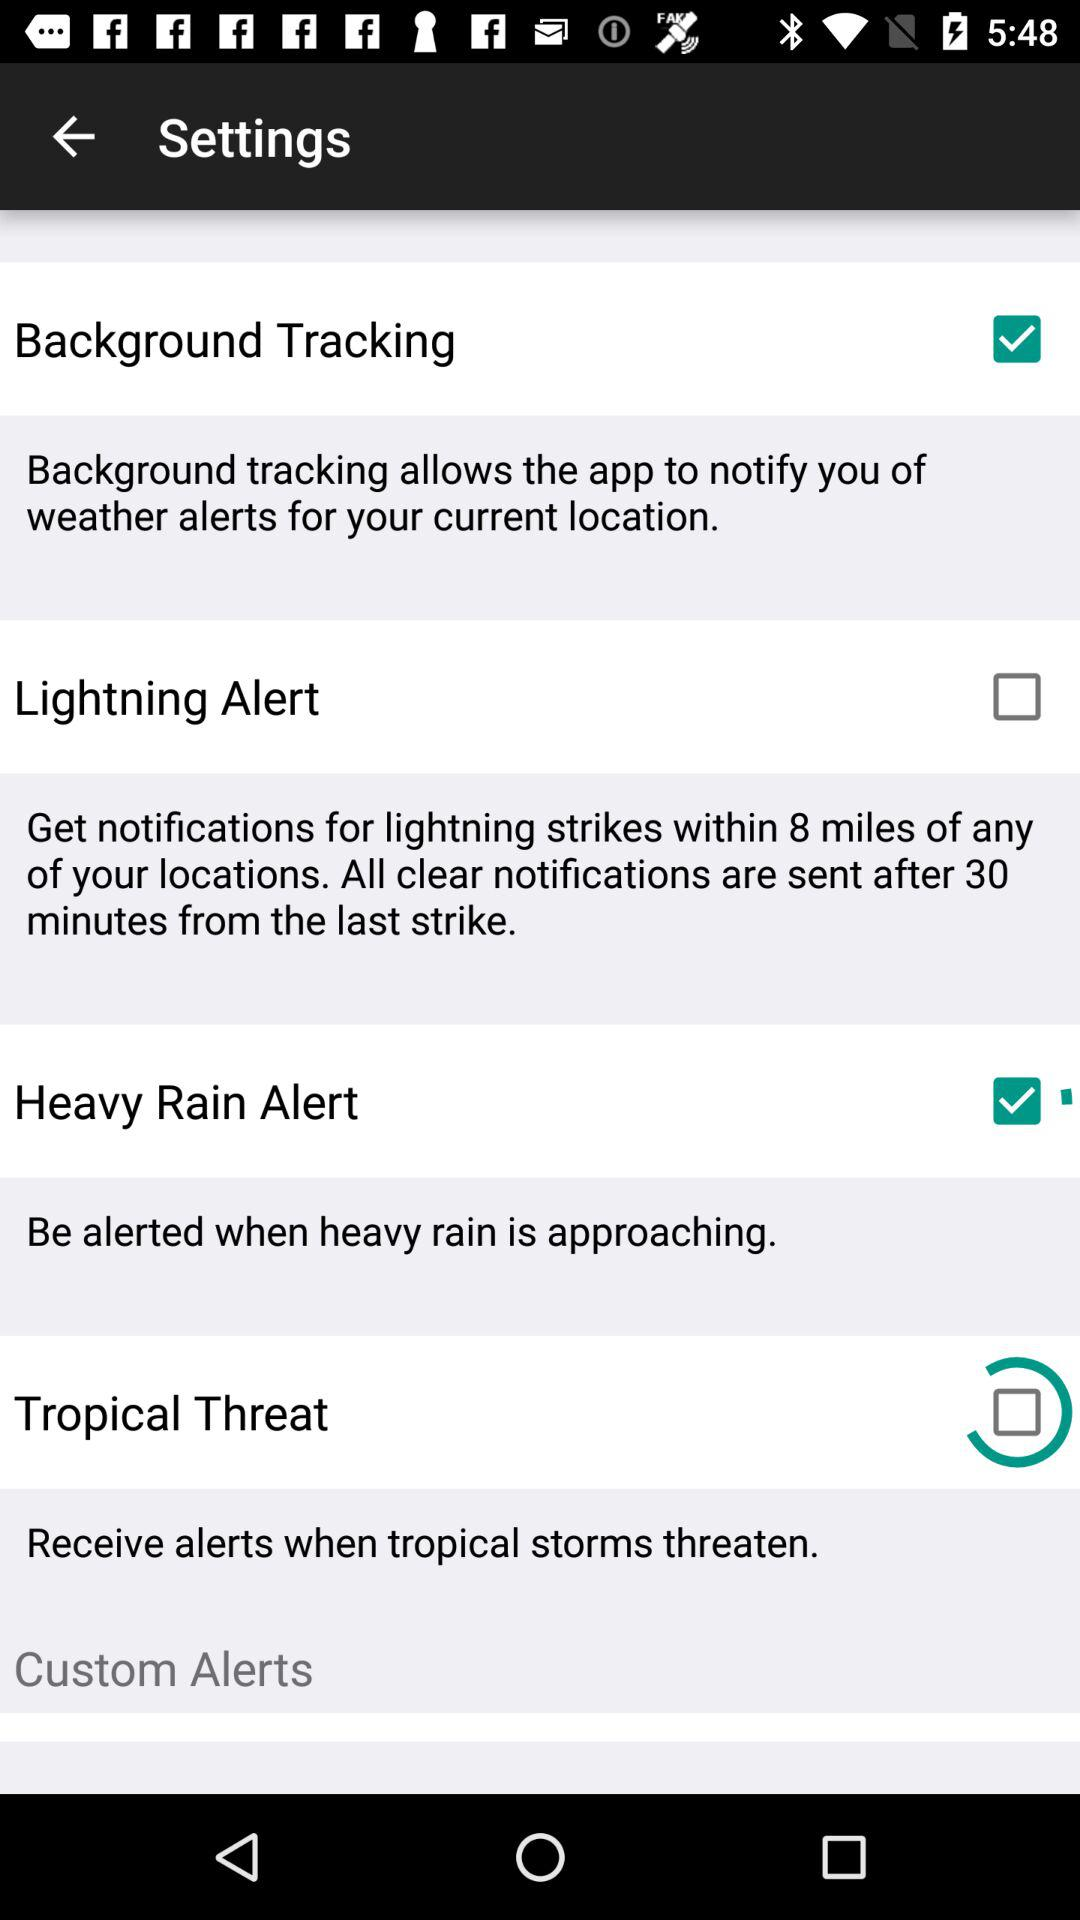What are the checked setting options? The checked setting options are "Background Tracking" and "Heavy Rain Alert". 